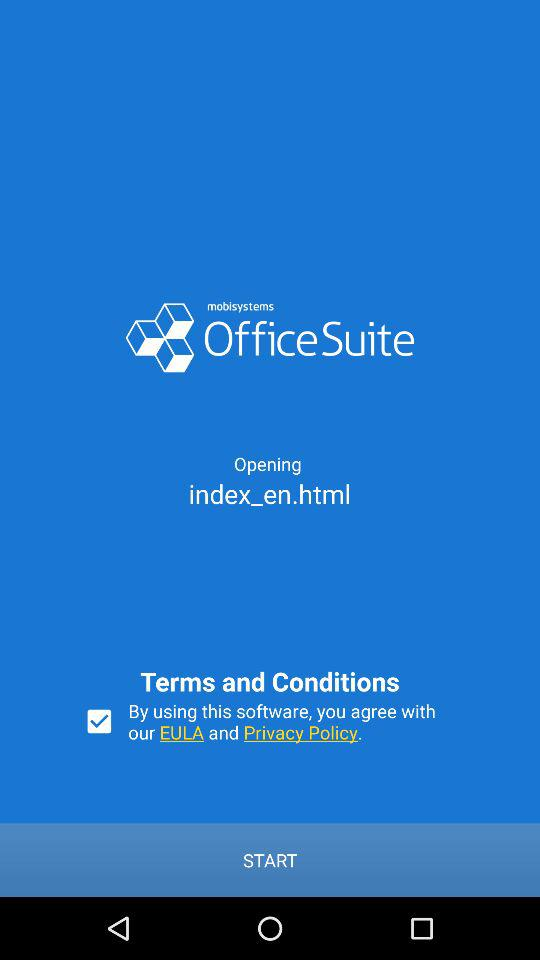What is the status of the option that includes agreement to the "EULA" and "Privacy Policy"? The status is "on". 